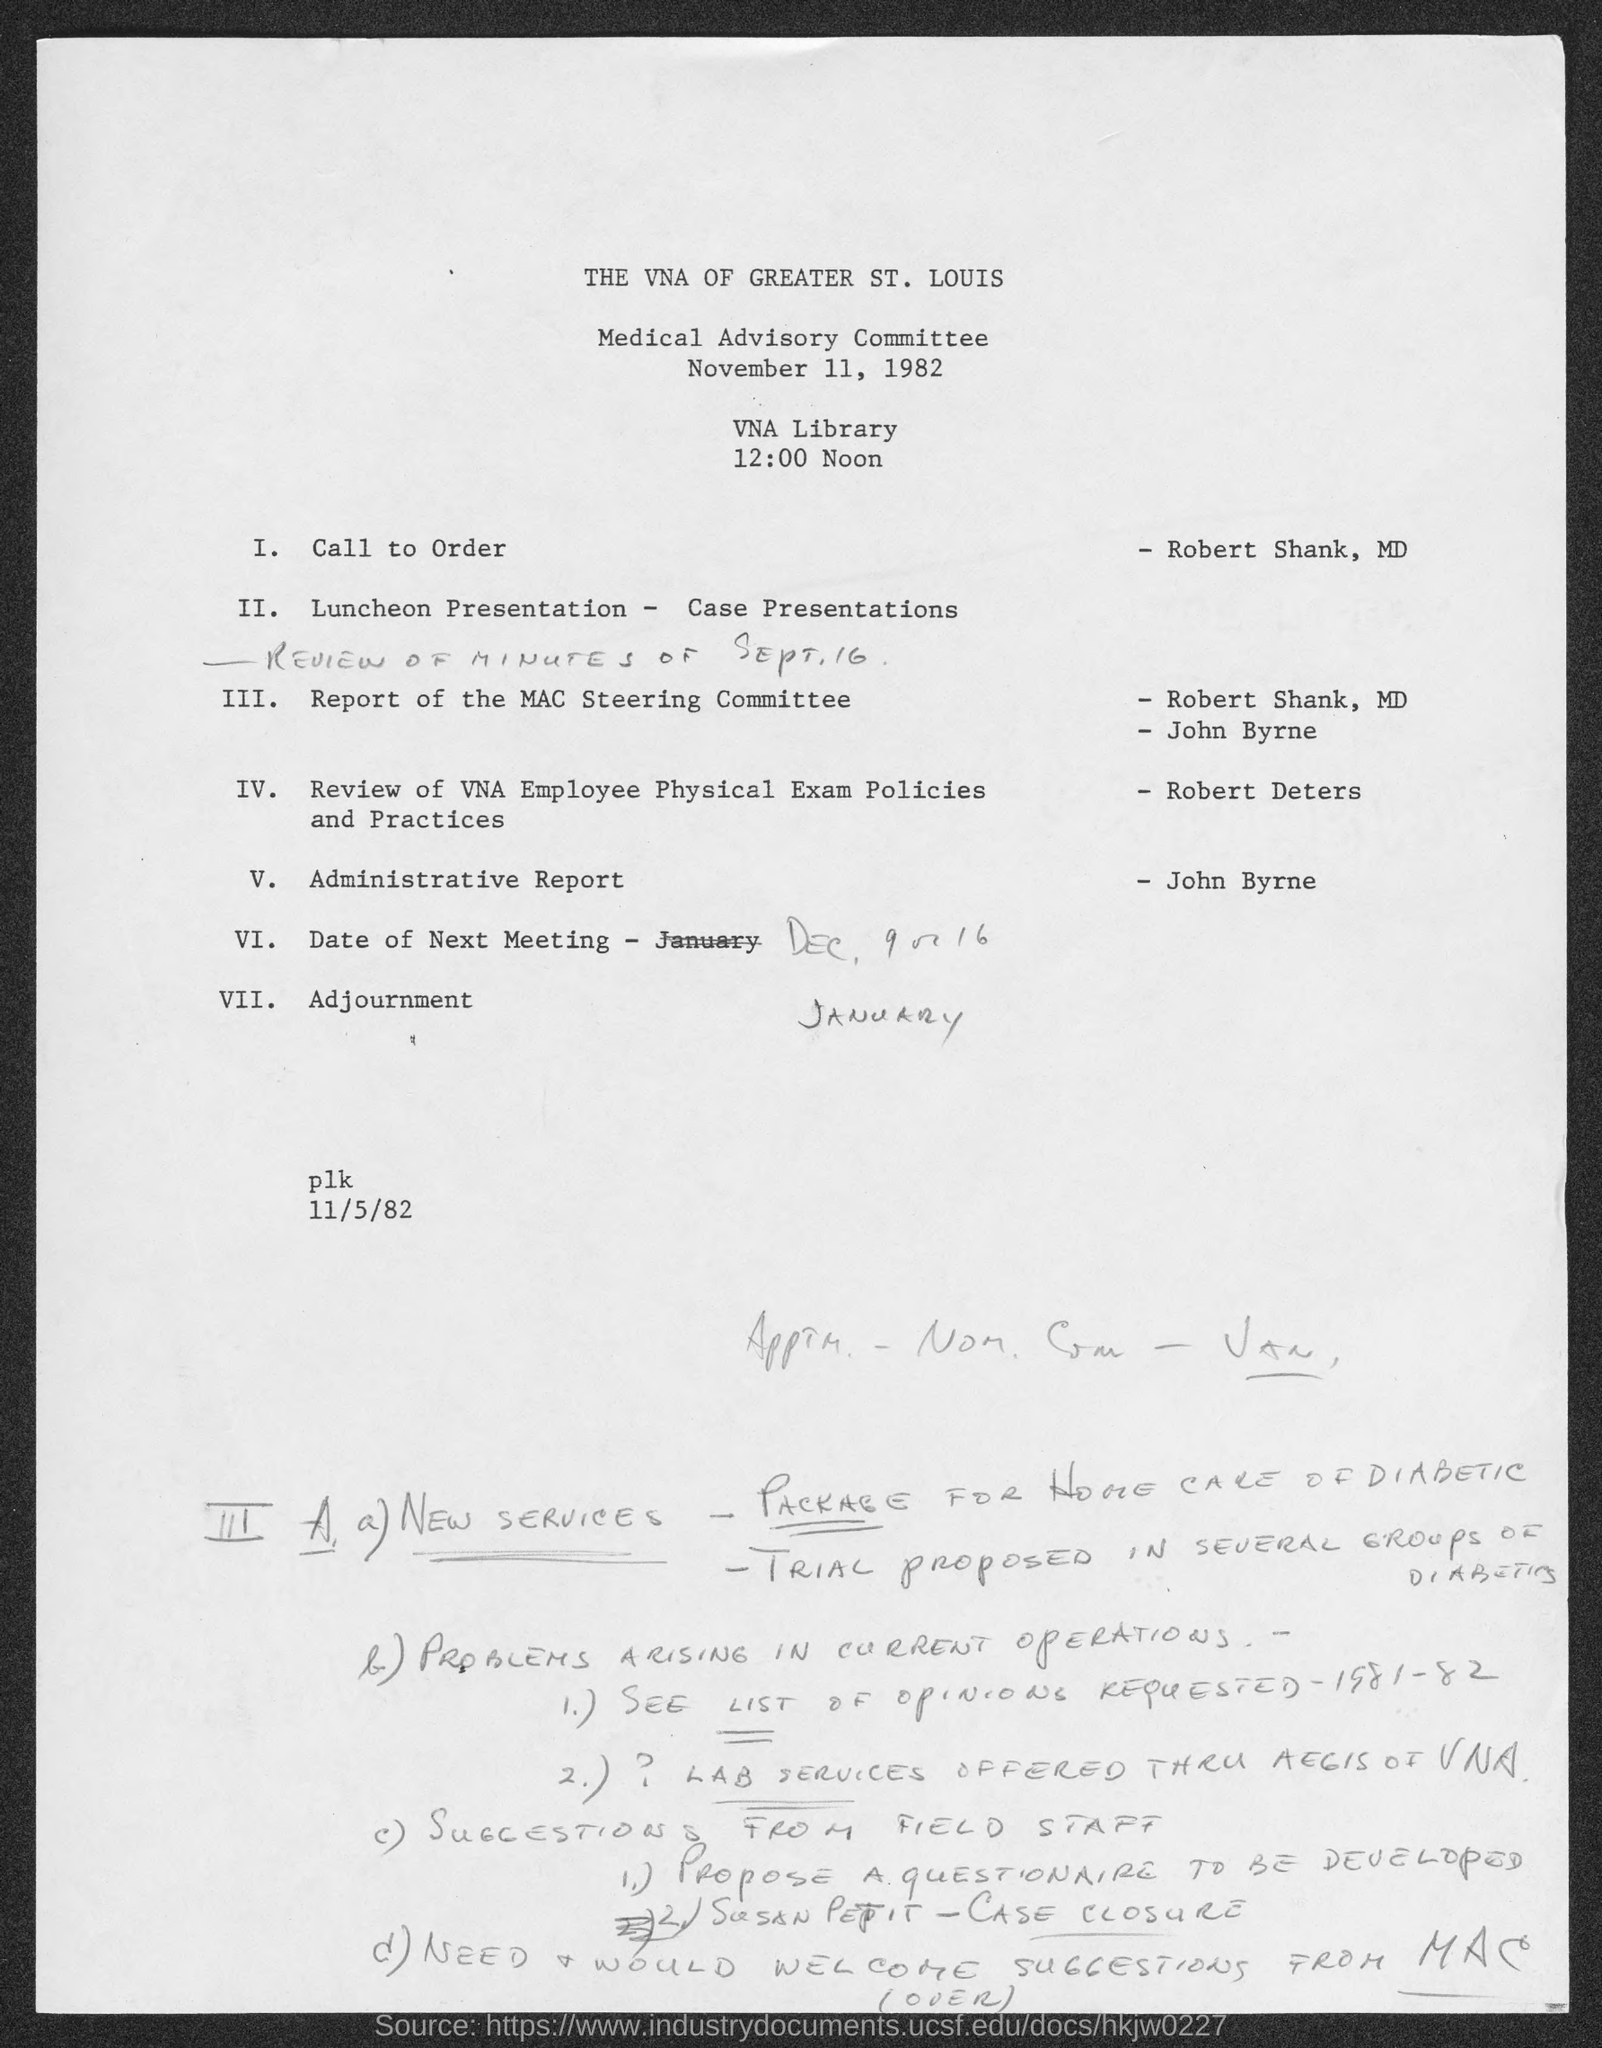Identify some key points in this picture. The Medical Advisory committee is held at 12:00 noon. The Medical Advisory committee is held at the VNA Library. The Medical Advisory committee was held on November 11, 1982. 